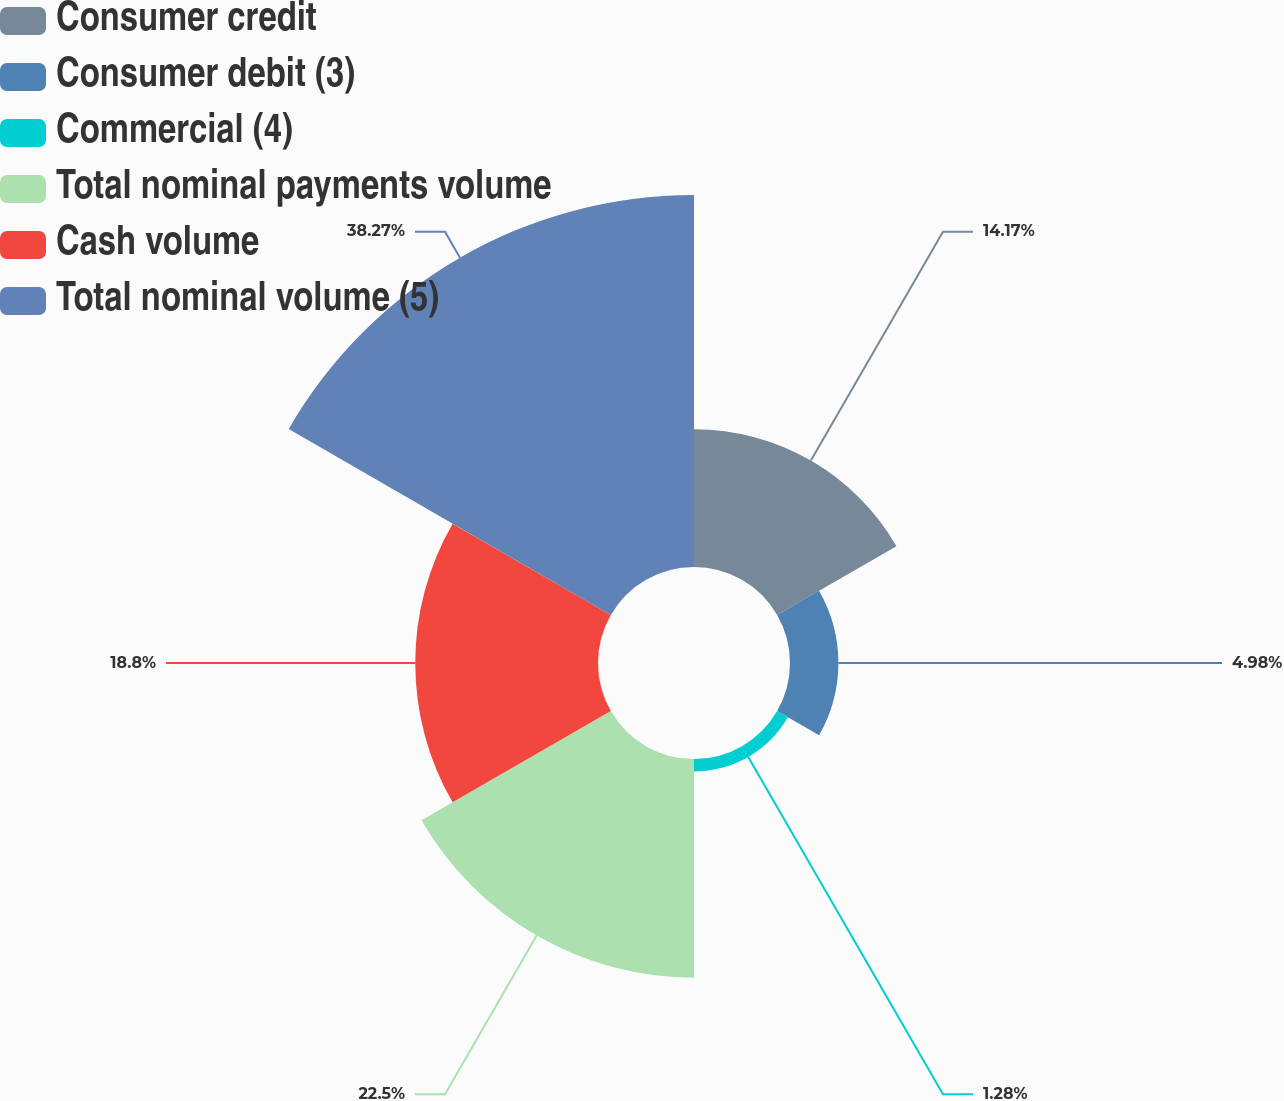Convert chart to OTSL. <chart><loc_0><loc_0><loc_500><loc_500><pie_chart><fcel>Consumer credit<fcel>Consumer debit (3)<fcel>Commercial (4)<fcel>Total nominal payments volume<fcel>Cash volume<fcel>Total nominal volume (5)<nl><fcel>14.17%<fcel>4.98%<fcel>1.28%<fcel>22.5%<fcel>18.8%<fcel>38.27%<nl></chart> 